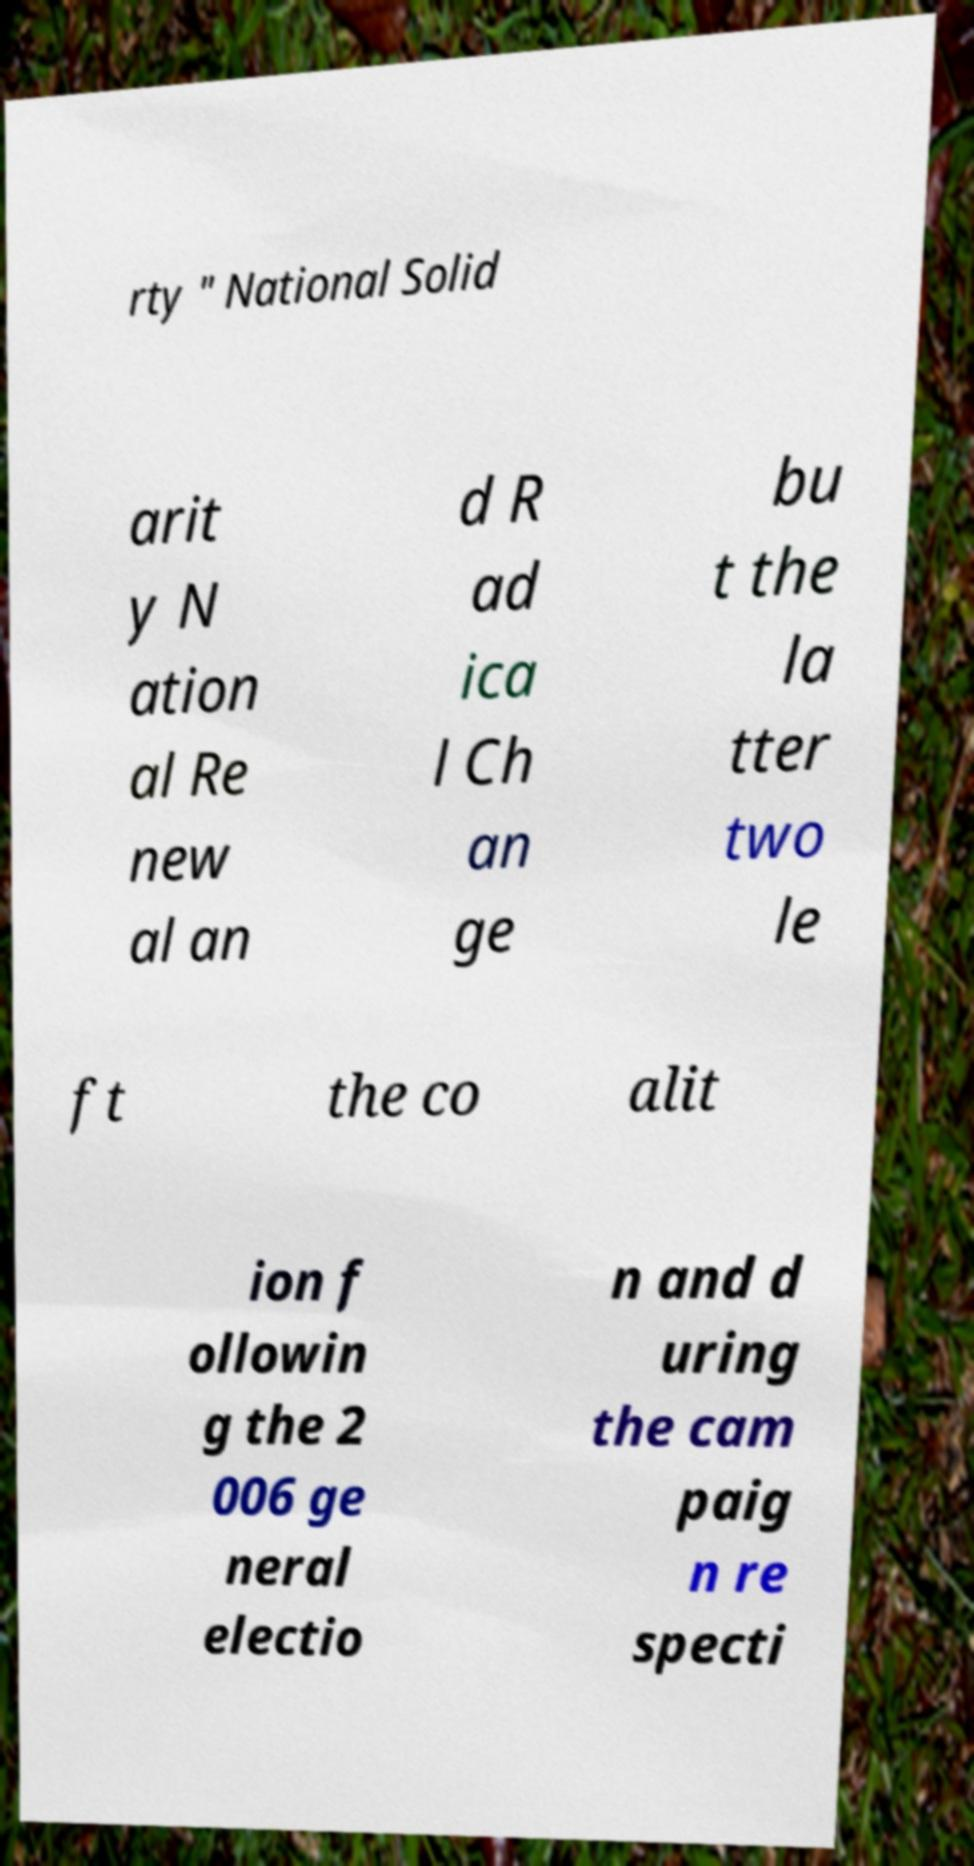For documentation purposes, I need the text within this image transcribed. Could you provide that? rty " National Solid arit y N ation al Re new al an d R ad ica l Ch an ge bu t the la tter two le ft the co alit ion f ollowin g the 2 006 ge neral electio n and d uring the cam paig n re specti 